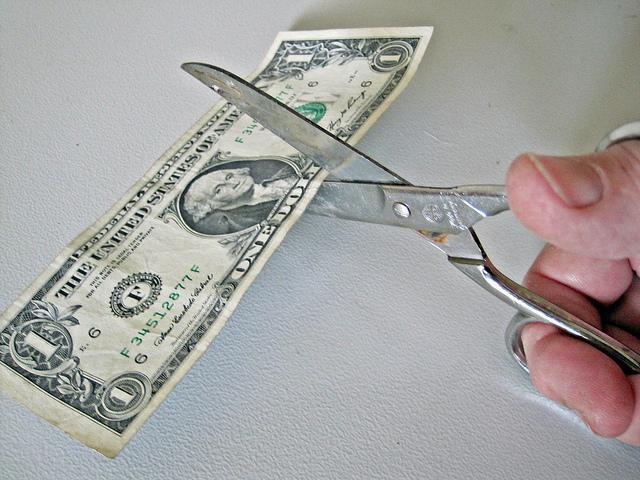How many orange stripes are on the sail?
Give a very brief answer. 0. 